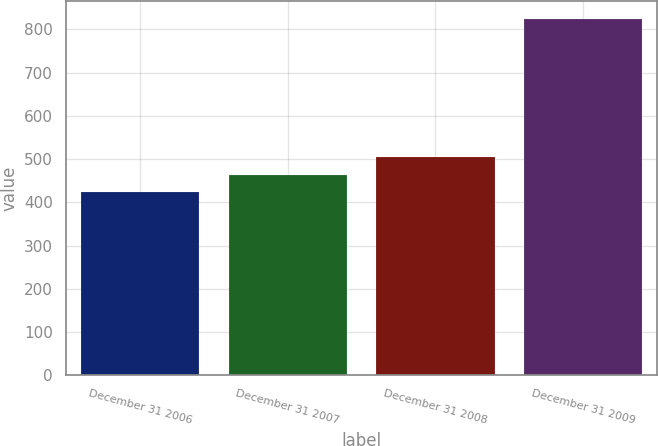Convert chart. <chart><loc_0><loc_0><loc_500><loc_500><bar_chart><fcel>December 31 2006<fcel>December 31 2007<fcel>December 31 2008<fcel>December 31 2009<nl><fcel>424<fcel>464<fcel>504<fcel>824<nl></chart> 